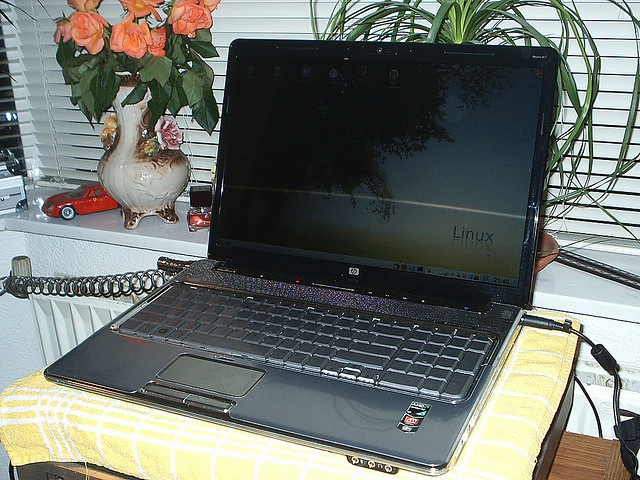Describe the objects in this image and their specific colors. I can see laptop in black, gray, and purple tones, potted plant in black, white, gray, and darkgreen tones, vase in black, darkgray, gray, and maroon tones, and car in black, brown, maroon, and gray tones in this image. 